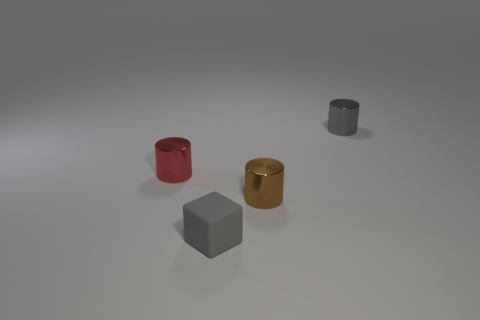There is a cylinder that is the same color as the matte cube; what material is it?
Your response must be concise. Metal. Is there a brown metallic object that is right of the small gray thing that is in front of the small gray shiny object?
Provide a succinct answer. Yes. What material is the brown cylinder?
Offer a terse response. Metal. There is a gray cylinder; are there any tiny objects to the left of it?
Your response must be concise. Yes. The red metallic thing that is the same shape as the small brown shiny object is what size?
Provide a succinct answer. Small. Is the number of gray rubber objects that are to the right of the tiny gray metal object the same as the number of metallic cylinders that are behind the brown metallic cylinder?
Provide a succinct answer. No. What number of big blue metal blocks are there?
Provide a succinct answer. 0. Is the number of small red shiny objects that are to the left of the brown thing greater than the number of gray rubber blocks?
Make the answer very short. No. There is a gray thing that is behind the tiny gray cube; what is its material?
Offer a very short reply. Metal. How many things are the same color as the tiny matte block?
Provide a succinct answer. 1. 